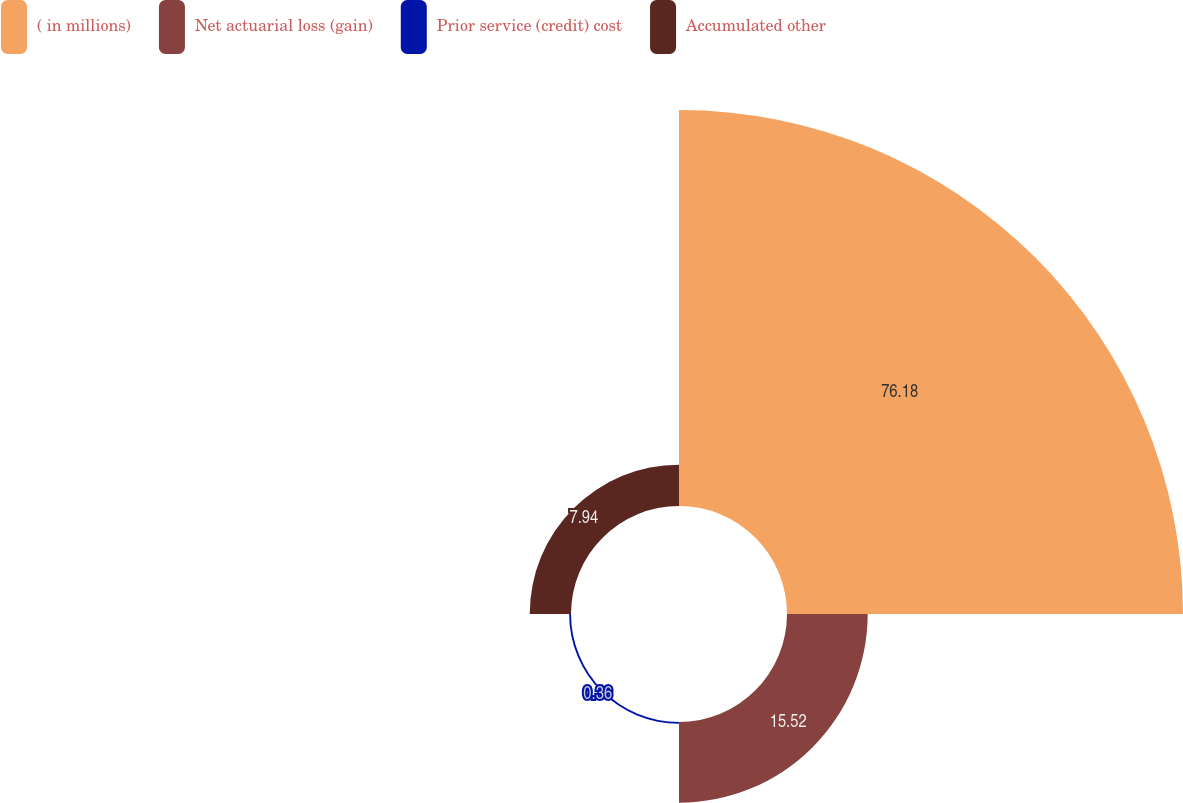<chart> <loc_0><loc_0><loc_500><loc_500><pie_chart><fcel>( in millions)<fcel>Net actuarial loss (gain)<fcel>Prior service (credit) cost<fcel>Accumulated other<nl><fcel>76.17%<fcel>15.52%<fcel>0.36%<fcel>7.94%<nl></chart> 